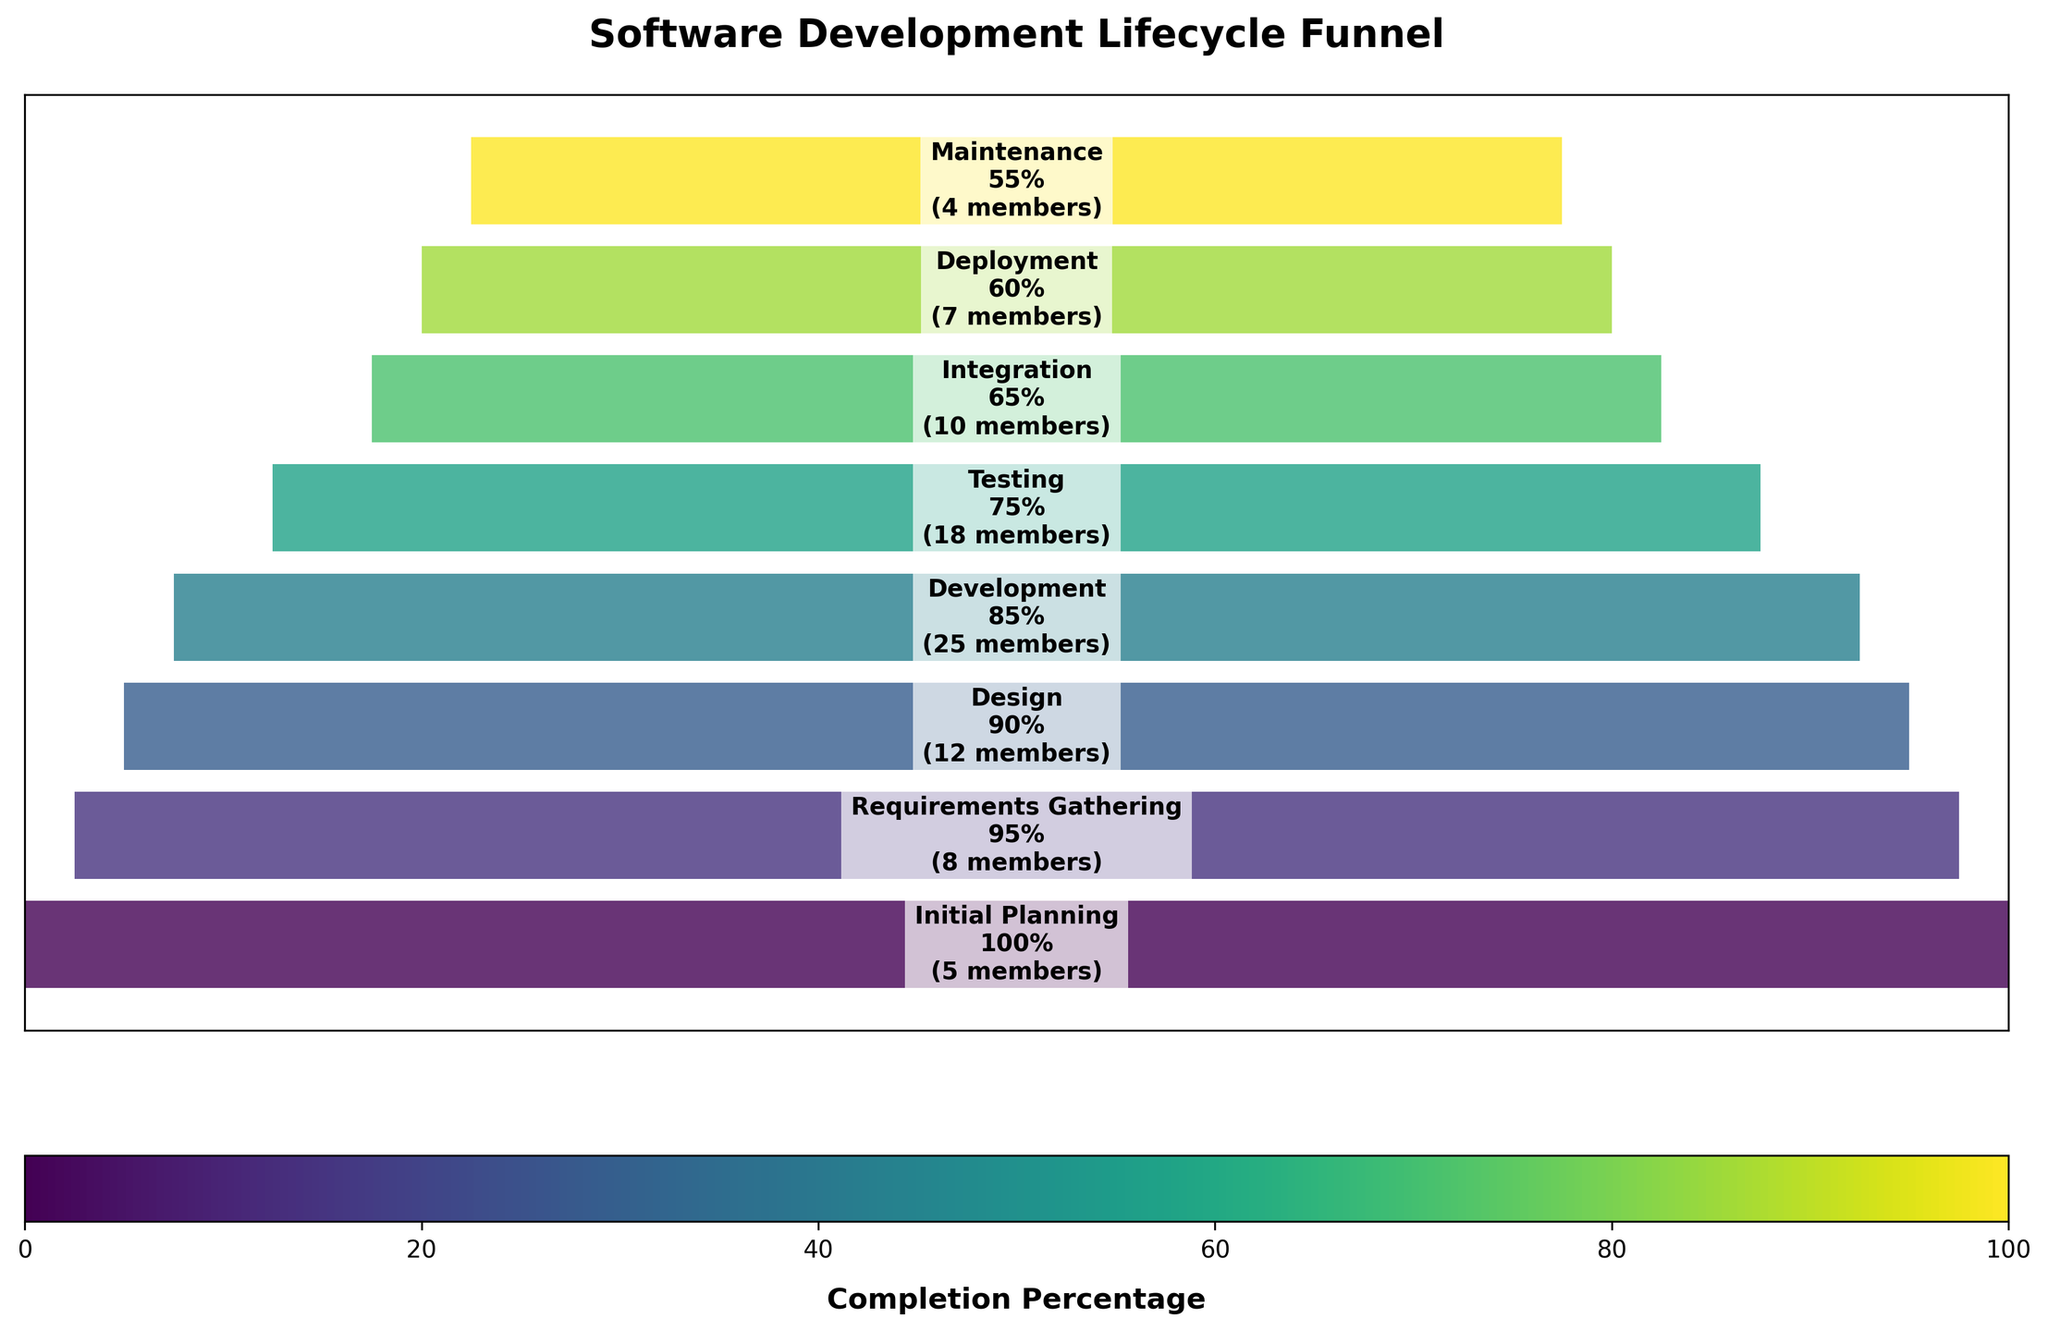What is the title of the chart? The title is located at the top of the figure and is typically bold and larger in font size compared to other text elements on the chart. It states the main topic or summary of the visualized data.
Answer: Software Development Lifecycle Funnel How many stages are depicted in the funnel chart? By counting the distinct sections or labels along the central vertical axis of the chart, each representing a different stage, we can determine the total number of stages shown.
Answer: 8 Which stage has the highest team size? To identify the stage with the highest team size, locate the stage with the largest numerical value next to its name on the chart. Development has 25 members, which is the highest in the chart.
Answer: Development What is the percentage completion at the Testing stage? Find the Testing stage label on the chart and look at the percentage value next to it. The Testing stage is shown with a percentage of 75%.
Answer: 75% What is the sum of team sizes for the Initial Planning and Deployment stages? Locate the stages Initial Planning and Deployment, then add their respective team sizes (5 + 7).
Answer: 12 How much smaller is the team size during Maintenance compared to Development? Locate the stages Maintenance and Development, then subtract the team size of Maintenance from Development (25 - 4).
Answer: 21 Which stage experiences the largest drop in percentage completion from the previous stage, and by how much? By comparing the percentage values of consecutive stages, we look for the largest difference. Development (85%) to Testing (75%) has the largest drop of 10%.
Answer: Testing, by 10% What percentage of the team size is reduced from the Design stage to the Integration stage? Locate Design and Integration stages with their team sizes (12 and 10, respectively). Calculate the percentage decrease ((12 - 10) / 12 * 100).
Answer: 16.67% Which stages have less than 10 team members? Identify stages where the team size value is less than 10. These stages are Initial Planning (5), Integration (10, but considered borderline), Deployment (7), and Maintenance (4).
Answer: Initial Planning, Deployment, Maintenance Which stage has a percentage completion exactly halfway between Initial Planning and Maintenance? Initial Planning has 100% and Maintenance has 55%, so halfway is (100 + 55) / 2 = 77.5%. Locate the stage closest to this value, which is Testing at 75%.
Answer: Testing 